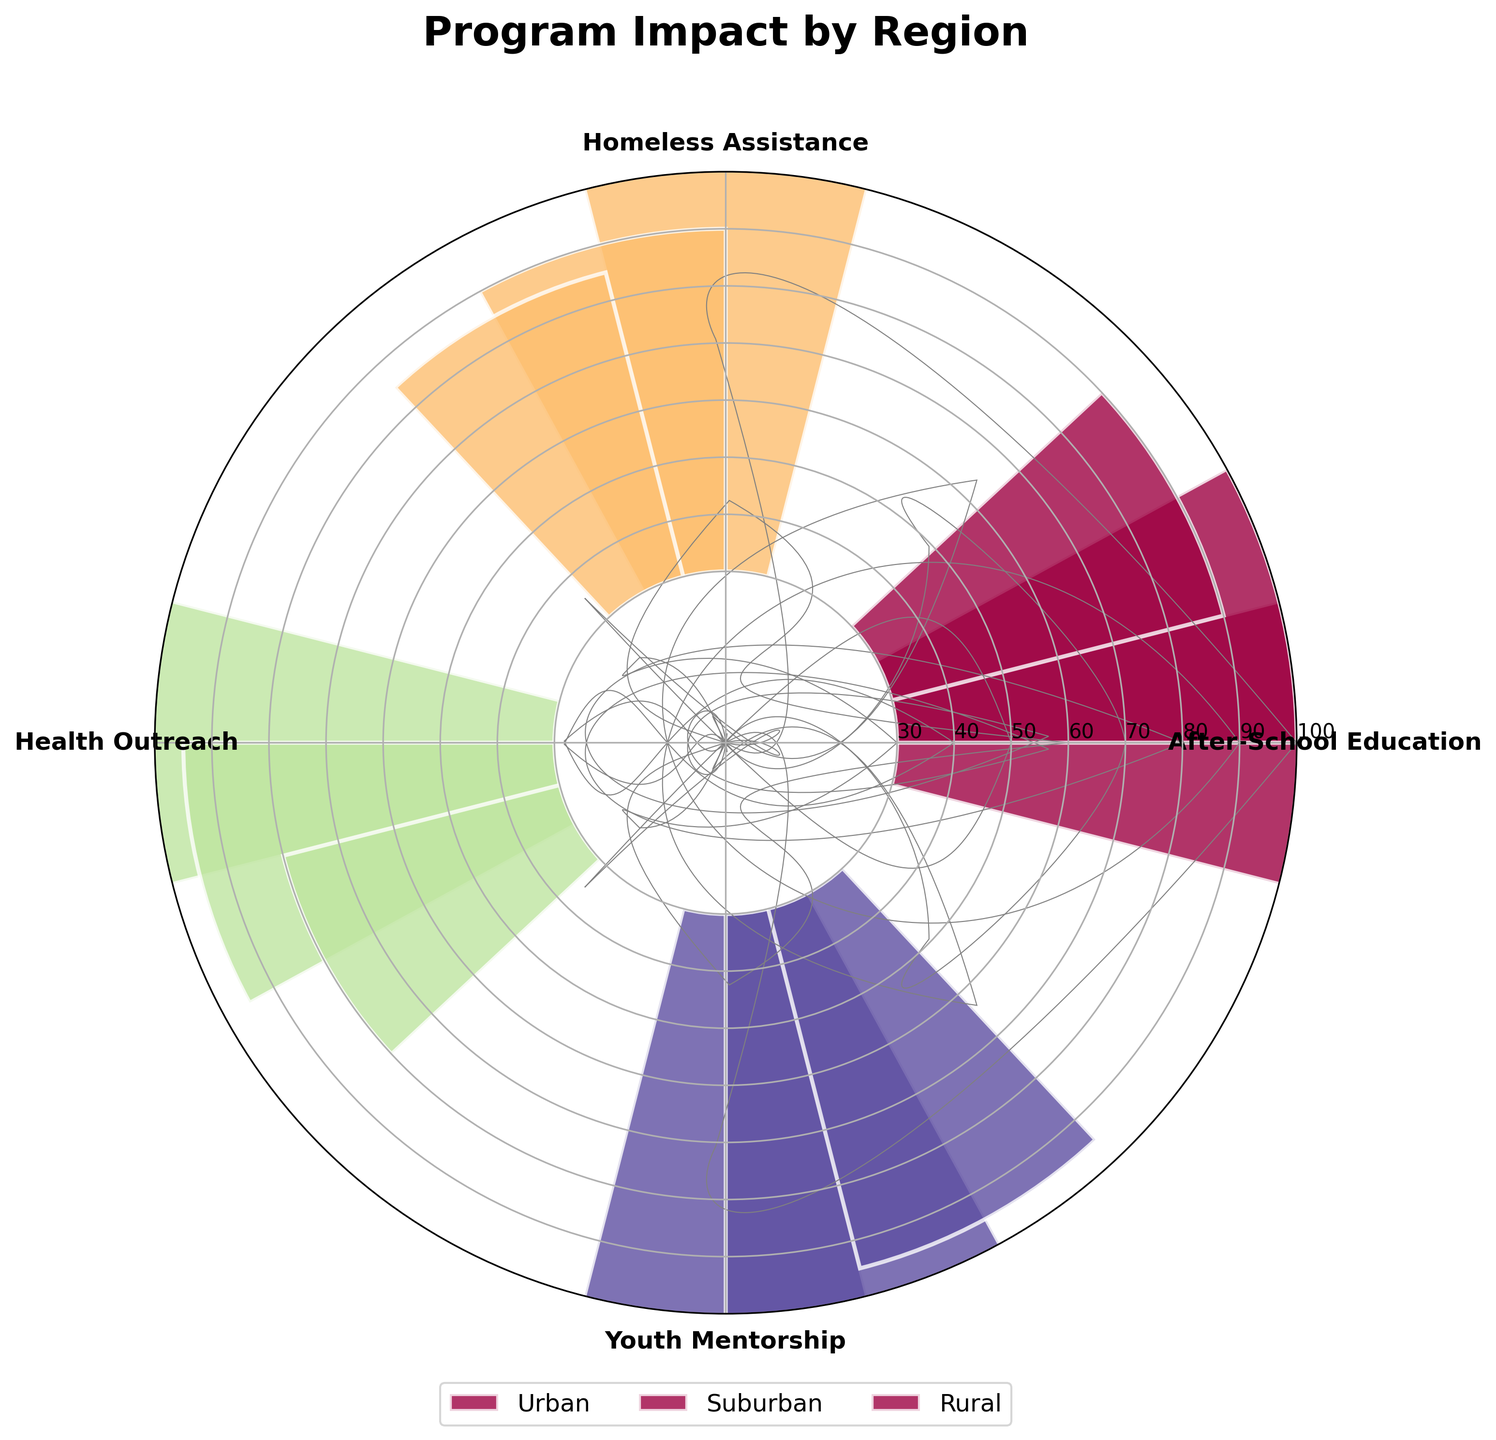How many programs are shown in the rose chart? The figure displays a segment for each program. By counting the number of segments or tick labels around the circle, we can determine the number of programs.
Answer: 4 What is the title of the rose chart? The title is located at the top of the figure, usually in a larger and bold font.
Answer: Program Impact by Region Which region has the highest impact score for Homeless Assistance? To determine this, look at the segment labeled "Homeless Assistance" and compare the heights of the bars for each region within this segment. The tallest bar represents the highest impact score.
Answer: Urban What is the range of impact scores for Youth Mentorship across all regions? First, identify the bars corresponding to "Youth Mentorship" and read their values. The range is calculated by subtracting the lowest score from the highest score. The scores are 80 (Urban), 75 (Suburban), and 65 (Rural). The range is 80 - 65.
Answer: 15 How does the impact score for Health Outreach in Urban areas compare to Rural areas? Compare the height of the "Health Outreach" segments for Urban (75) and Rural (50) regions.
Answer: Urban is higher by 25 Which region has the lowest overall impact score across all programs? Sum the impact scores for each region individually and compare the totals. Urban (85+90+75+80 = 330), Suburban (70+60+65+75 = 270), and Rural (60+55+50+65 = 230). The region with the smallest sum is the lowest.
Answer: Rural Which program has the smallest impact score in Suburban areas? Identify the segments corresponding to the Suburban region and find the bar with the shortest height, which represents the smallest impact score.
Answer: Homeless Assistance Is the impact score for After-School Education in Urban areas greater than or equal to the score for Homeless Assistance in Suburban areas? Compare the heights of the "After-School Education" bar in Urban (85) and "Homeless Assistance" bar in Suburban (60). Since 85 ≥ 60, the condition holds true.
Answer: Yes What is the average impact score for programs in Suburban areas? Add the impact scores for all programs in the Suburban region and divide by the number of programs: (70 + 60 + 65 + 75) / 4. This gives the average impact score.
Answer: 67.5 Which program shows the most consistent impact score across all regions? Observe each program's bar heights across the regions. The program with the smallest variation in heights represents the most consistent impact score. By estimating, "Youth Mentorship" varies the least, with scores of 80 (Urban), 75 (Suburban), and 65 (Rural).
Answer: Youth Mentorship 